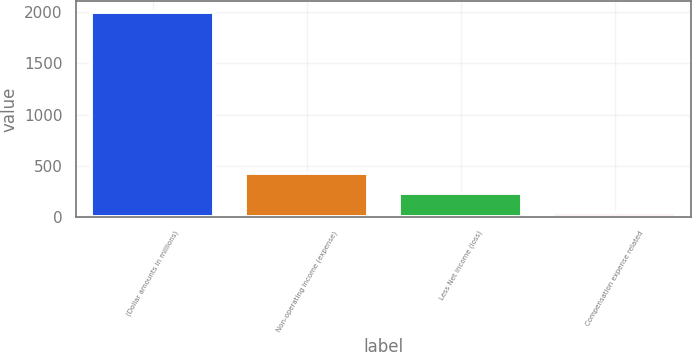Convert chart. <chart><loc_0><loc_0><loc_500><loc_500><bar_chart><fcel>(Dollar amounts in millions)<fcel>Non-operating income (expense)<fcel>Less Net income (loss)<fcel>Compensation expense related<nl><fcel>2008<fcel>432<fcel>235<fcel>38<nl></chart> 